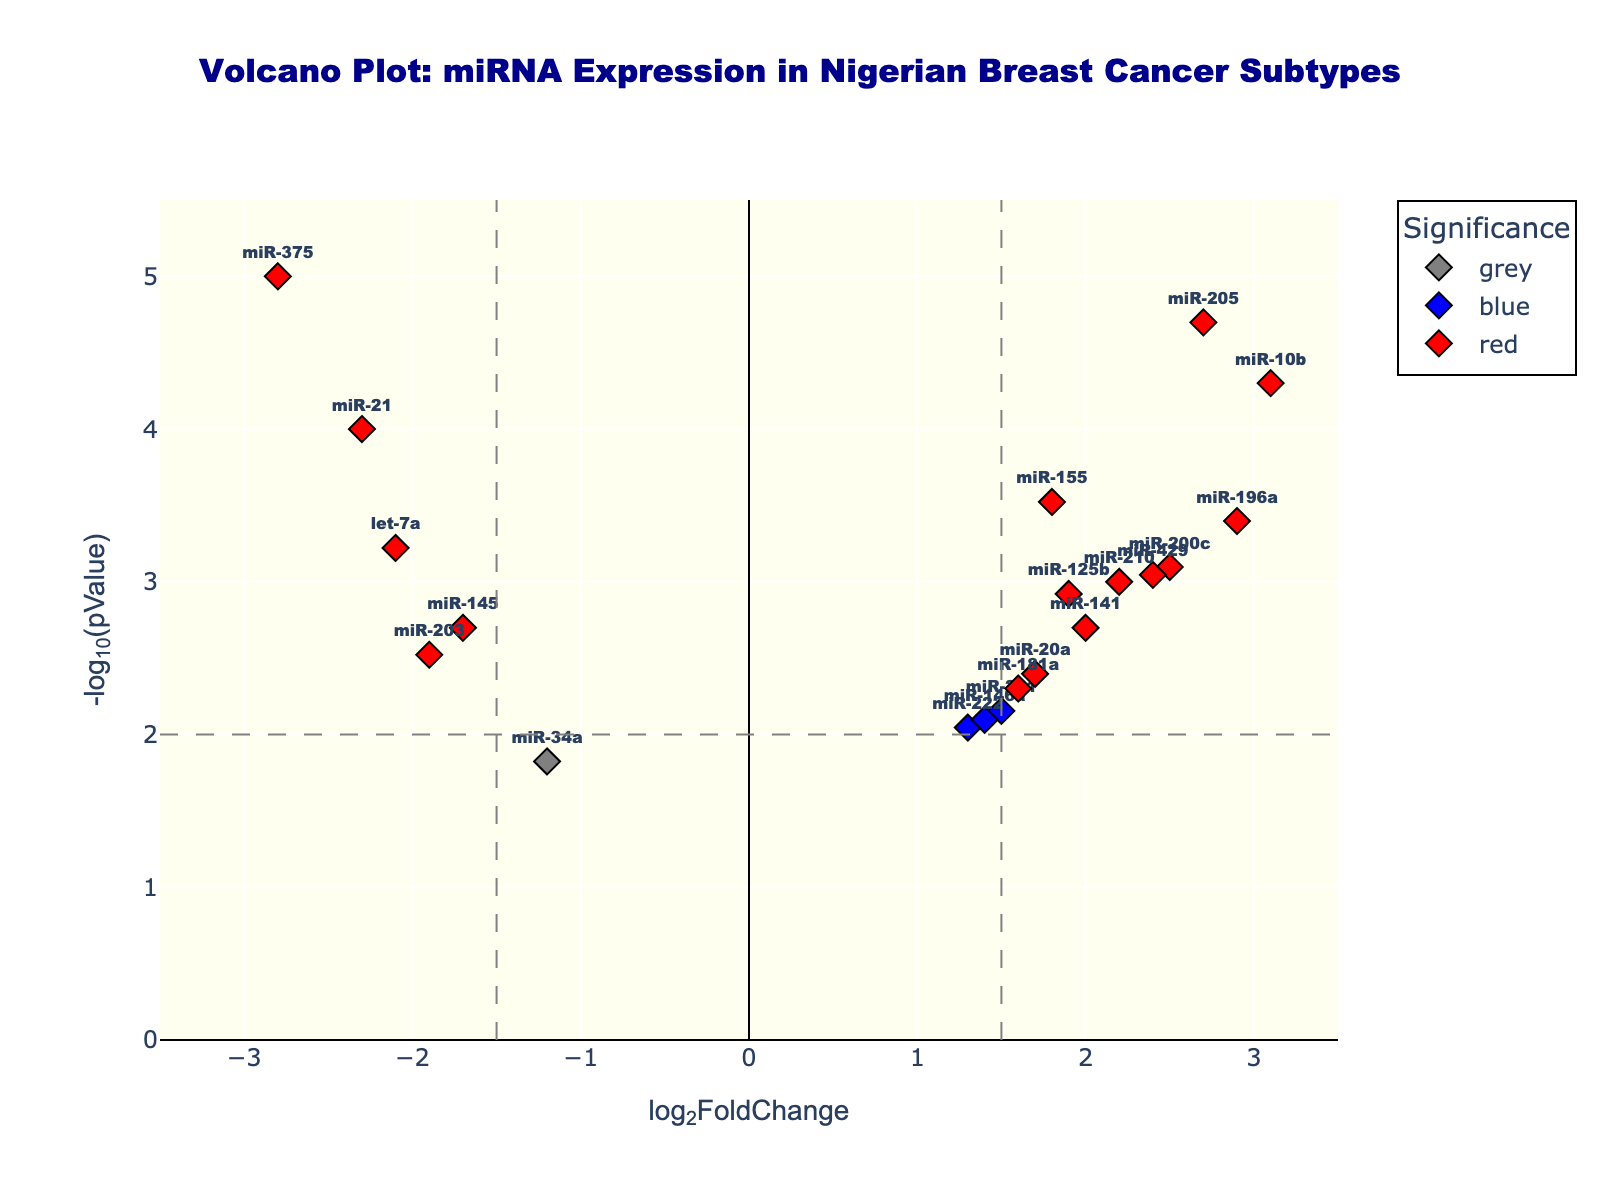What is the main title of the plot? The title is usually found at the top of the plot and provides an overview of what the plot represents.
Answer: Volcano Plot: miRNA Expression in Nigerian Breast Cancer Subtypes How many miRNAs have a log2FoldChange greater than 2? To answer this, look for data points where the x-axis value (log2FoldChange) is greater than 2. There are five such data points.
Answer: 5 Which miRNA has the lowest pValue? The miRNA with the lowest pValue will have the highest corresponding -log10(pValue) on the y-axis. The miR-375 has the highest point on the y-axis.
Answer: miR-375 How many miRNAs are colored red? The red color indicates miRNAs with both high significance (low pValue) and high fold change. Checking the plot, there are seven red data points.
Answer: 7 What is the log2FoldChange and pValue for miR-21? Locate miR-21 in the plot, and the values for log2FoldChange and -log10(pValue) can be read directly or inferred. miR-21 has a log2FoldChange of -2.3 and a -log10(pValue) of 4 (since pValue is 0.0001).
Answer: log2FoldChange: -2.3, pValue: 0.0001 Identify the miRNA with the highest log2FoldChange. The miRNA with the highest positive value on the x-axis (log2FoldChange) is miR-10b, which has a log2FoldChange of 3.1.
Answer: miR-10b Which miRNA has the least significant pValue above the threshold of 0.01? For pValues above 0.01, identify the lowest -log10(pValue). miR-34a shows the smallest significance above this threshold.
Answer: miR-34a Compare the log2FoldChange of miR-145 and miR-125b. Which one is higher? Find both miRNAs in the plot and compare their x-axis positions. miR-125b has a higher log2FoldChange (1.9) compared to miR-145 (-1.7).
Answer: miR-125b Is there any miRNA with a log2FoldChange of around 2 and a pValue less than 0.01? Look for data points around x = 2 and above y = 2. miRNAs miR-200c, miR-210, and miR-141 fit these criteria.
Answer: Yes Which miRNA falls close to the origin of the plot? The origin is where both the axes intersect, near log2FoldChange of 0 and -log10(pValue) of 0. miR-222 is close to the origin.
Answer: miR-222 